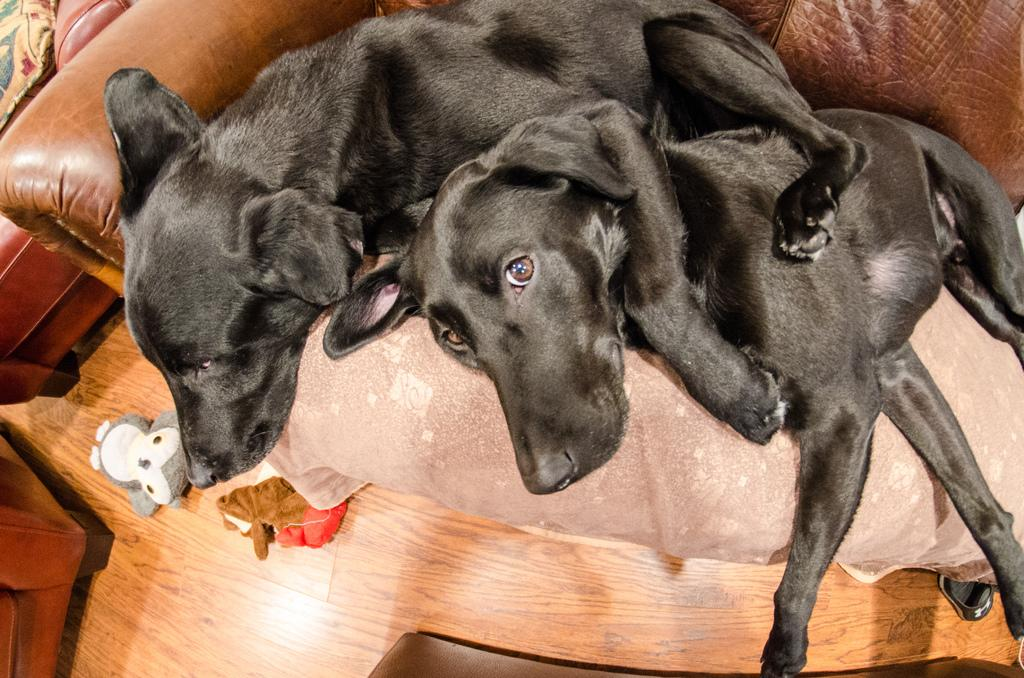How many dogs are present in the image? There are two dogs in the image. What are the dogs doing in the image? The dogs are on a sofa. What type of flooring is visible in the image? There is a wooden floor visible in the image. What type of bomb can be seen in the image? There is no bomb present in the image; it features two dogs on a sofa. What time of day is depicted in the image? The time of day is not discernible from the image, as there are no specific time indicators present. 